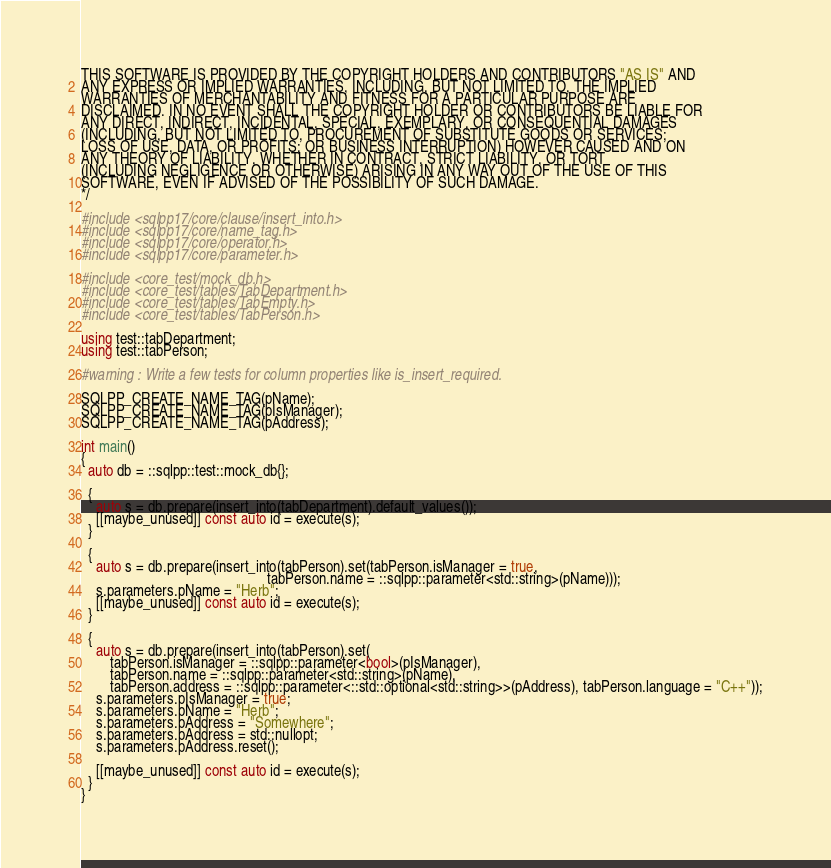Convert code to text. <code><loc_0><loc_0><loc_500><loc_500><_C++_>THIS SOFTWARE IS PROVIDED BY THE COPYRIGHT HOLDERS AND CONTRIBUTORS "AS IS" AND
ANY EXPRESS OR IMPLIED WARRANTIES, INCLUDING, BUT NOT LIMITED TO, THE IMPLIED
WARRANTIES OF MERCHANTABILITY AND FITNESS FOR A PARTICULAR PURPOSE ARE
DISCLAIMED. IN NO EVENT SHALL THE COPYRIGHT HOLDER OR CONTRIBUTORS BE LIABLE FOR
ANY DIRECT, INDIRECT, INCIDENTAL, SPECIAL, EXEMPLARY, OR CONSEQUENTIAL DAMAGES
(INCLUDING, BUT NOT LIMITED TO, PROCUREMENT OF SUBSTITUTE GOODS OR SERVICES;
LOSS OF USE, DATA, OR PROFITS; OR BUSINESS INTERRUPTION) HOWEVER CAUSED AND ON
ANY THEORY OF LIABILITY, WHETHER IN CONTRACT, STRICT LIABILITY, OR TORT
(INCLUDING NEGLIGENCE OR OTHERWISE) ARISING IN ANY WAY OUT OF THE USE OF THIS
SOFTWARE, EVEN IF ADVISED OF THE POSSIBILITY OF SUCH DAMAGE.
*/

#include <sqlpp17/core/clause/insert_into.h>
#include <sqlpp17/core/name_tag.h>
#include <sqlpp17/core/operator.h>
#include <sqlpp17/core/parameter.h>

#include <core_test/mock_db.h>
#include <core_test/tables/TabDepartment.h>
#include <core_test/tables/TabEmpty.h>
#include <core_test/tables/TabPerson.h>

using test::tabDepartment;
using test::tabPerson;

#warning : Write a few tests for column properties like is_insert_required.

SQLPP_CREATE_NAME_TAG(pName);
SQLPP_CREATE_NAME_TAG(pIsManager);
SQLPP_CREATE_NAME_TAG(pAddress);

int main()
{
  auto db = ::sqlpp::test::mock_db{};

  {
    auto s = db.prepare(insert_into(tabDepartment).default_values());
    [[maybe_unused]] const auto id = execute(s);
  }

  {
    auto s = db.prepare(insert_into(tabPerson).set(tabPerson.isManager = true,
                                                   tabPerson.name = ::sqlpp::parameter<std::string>(pName)));
    s.parameters.pName = "Herb";
    [[maybe_unused]] const auto id = execute(s);
  }

  {
    auto s = db.prepare(insert_into(tabPerson).set(
        tabPerson.isManager = ::sqlpp::parameter<bool>(pIsManager),
        tabPerson.name = ::sqlpp::parameter<std::string>(pName),
        tabPerson.address = ::sqlpp::parameter<::std::optional<std::string>>(pAddress), tabPerson.language = "C++"));
    s.parameters.pIsManager = true;
    s.parameters.pName = "Herb";
    s.parameters.pAddress = "Somewhere";
    s.parameters.pAddress = std::nullopt;
    s.parameters.pAddress.reset();

    [[maybe_unused]] const auto id = execute(s);
  }
}
</code> 